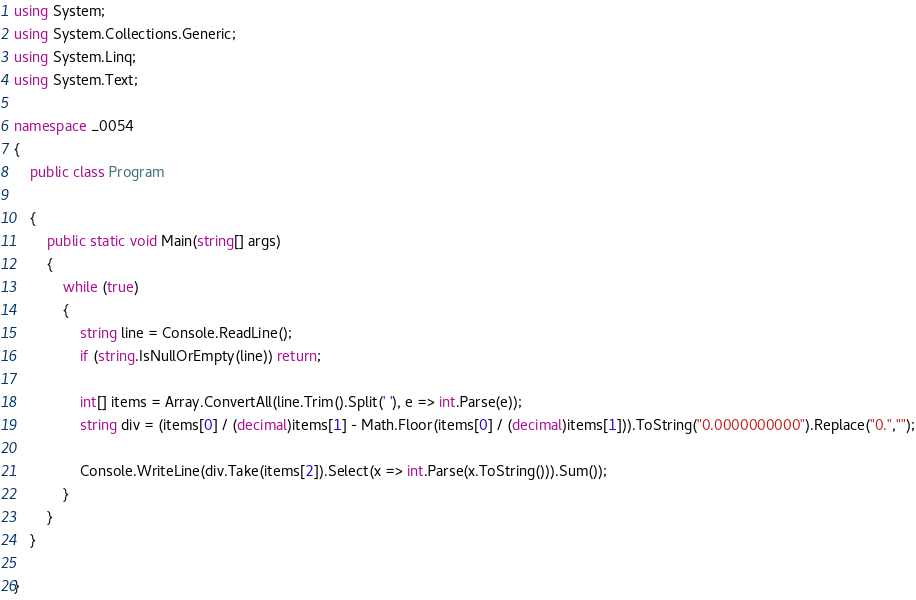Convert code to text. <code><loc_0><loc_0><loc_500><loc_500><_C#_>using System;
using System.Collections.Generic;
using System.Linq;
using System.Text;

namespace _0054
{
    public class Program

    {
        public static void Main(string[] args)
        {
            while (true)
            {
                string line = Console.ReadLine();
                if (string.IsNullOrEmpty(line)) return;

                int[] items = Array.ConvertAll(line.Trim().Split(' '), e => int.Parse(e));
                string div = (items[0] / (decimal)items[1] - Math.Floor(items[0] / (decimal)items[1])).ToString("0.0000000000").Replace("0.","");

                Console.WriteLine(div.Take(items[2]).Select(x => int.Parse(x.ToString())).Sum());
            }              
        }
    }

}

</code> 